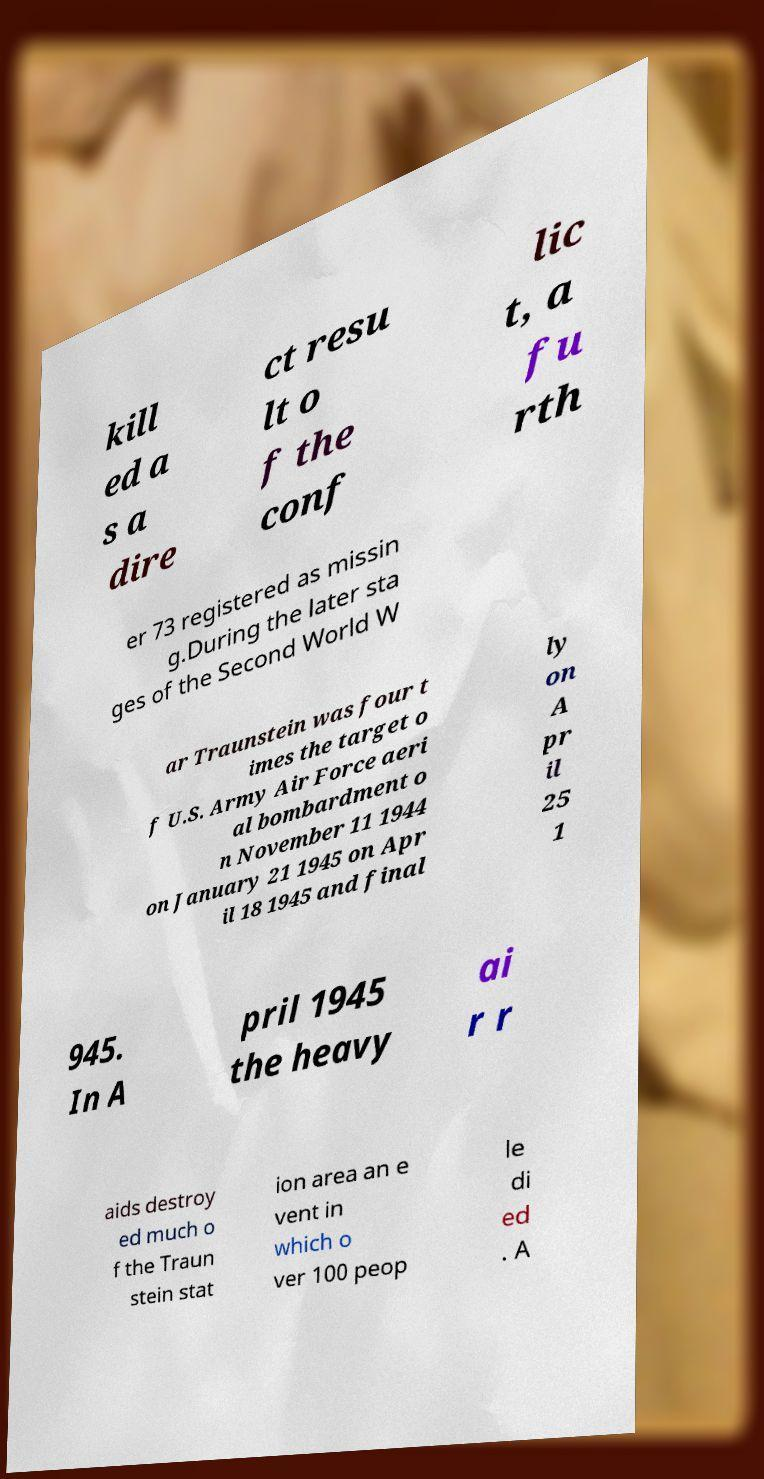I need the written content from this picture converted into text. Can you do that? kill ed a s a dire ct resu lt o f the conf lic t, a fu rth er 73 registered as missin g.During the later sta ges of the Second World W ar Traunstein was four t imes the target o f U.S. Army Air Force aeri al bombardment o n November 11 1944 on January 21 1945 on Apr il 18 1945 and final ly on A pr il 25 1 945. In A pril 1945 the heavy ai r r aids destroy ed much o f the Traun stein stat ion area an e vent in which o ver 100 peop le di ed . A 